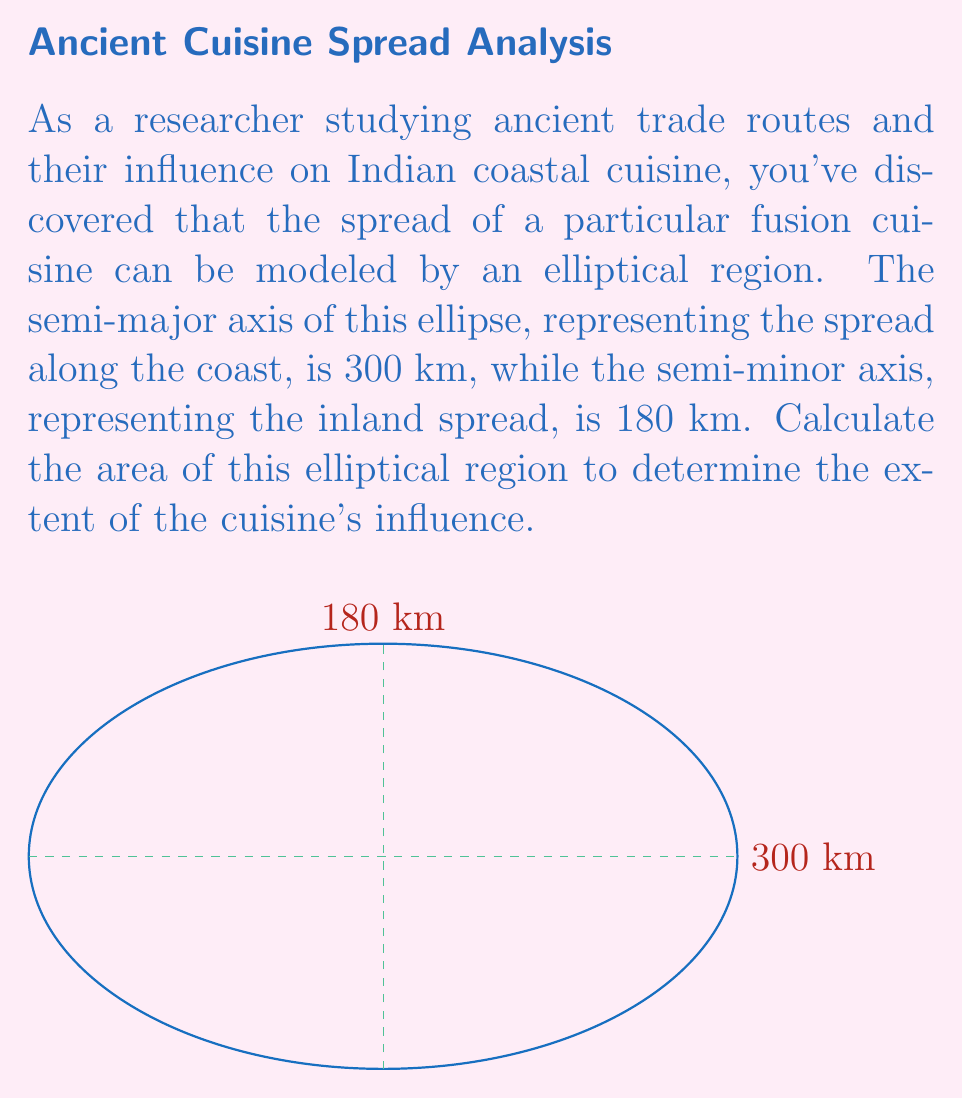Can you solve this math problem? Let's approach this step-by-step:

1) The area of an ellipse is given by the formula:

   $$A = \pi ab$$

   where $a$ is the length of the semi-major axis and $b$ is the length of the semi-minor axis.

2) In this case, we have:
   $a = 300$ km (semi-major axis)
   $b = 180$ km (semi-minor axis)

3) Substituting these values into our formula:

   $$A = \pi (300)(180)$$

4) Simplify:
   $$A = 54000\pi \text{ km}^2$$

5) To get a numerical value, we can use $\pi \approx 3.14159$:

   $$A \approx 54000 * 3.14159 \text{ km}^2$$
   $$A \approx 169645.86 \text{ km}^2$$

6) Rounding to the nearest whole number:

   $$A \approx 169646 \text{ km}^2$$

Therefore, the area of the elliptical region representing the spread of the fusion cuisine is approximately 169,646 square kilometers.
Answer: $169646 \text{ km}^2$ 